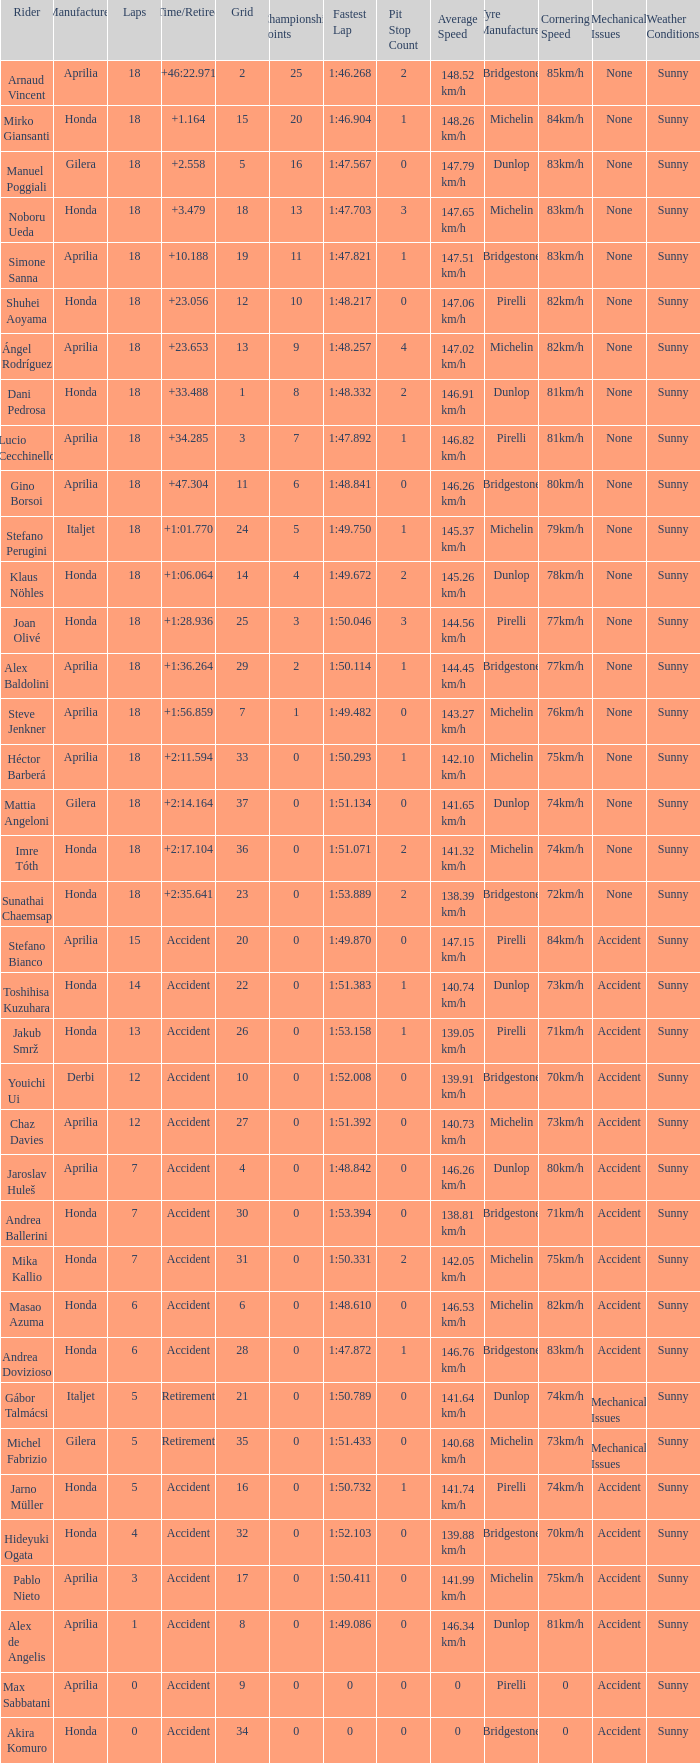Who is the rider with less than 15 laps, more than 32 grids, and an accident time/retired? Akira Komuro. 